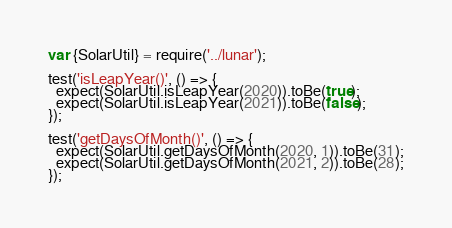<code> <loc_0><loc_0><loc_500><loc_500><_JavaScript_>var {SolarUtil} = require('../lunar');

test('isLeapYear()', () => {
  expect(SolarUtil.isLeapYear(2020)).toBe(true);
  expect(SolarUtil.isLeapYear(2021)).toBe(false);
});

test('getDaysOfMonth()', () => {
  expect(SolarUtil.getDaysOfMonth(2020, 1)).toBe(31);
  expect(SolarUtil.getDaysOfMonth(2021, 2)).toBe(28);
});
</code> 